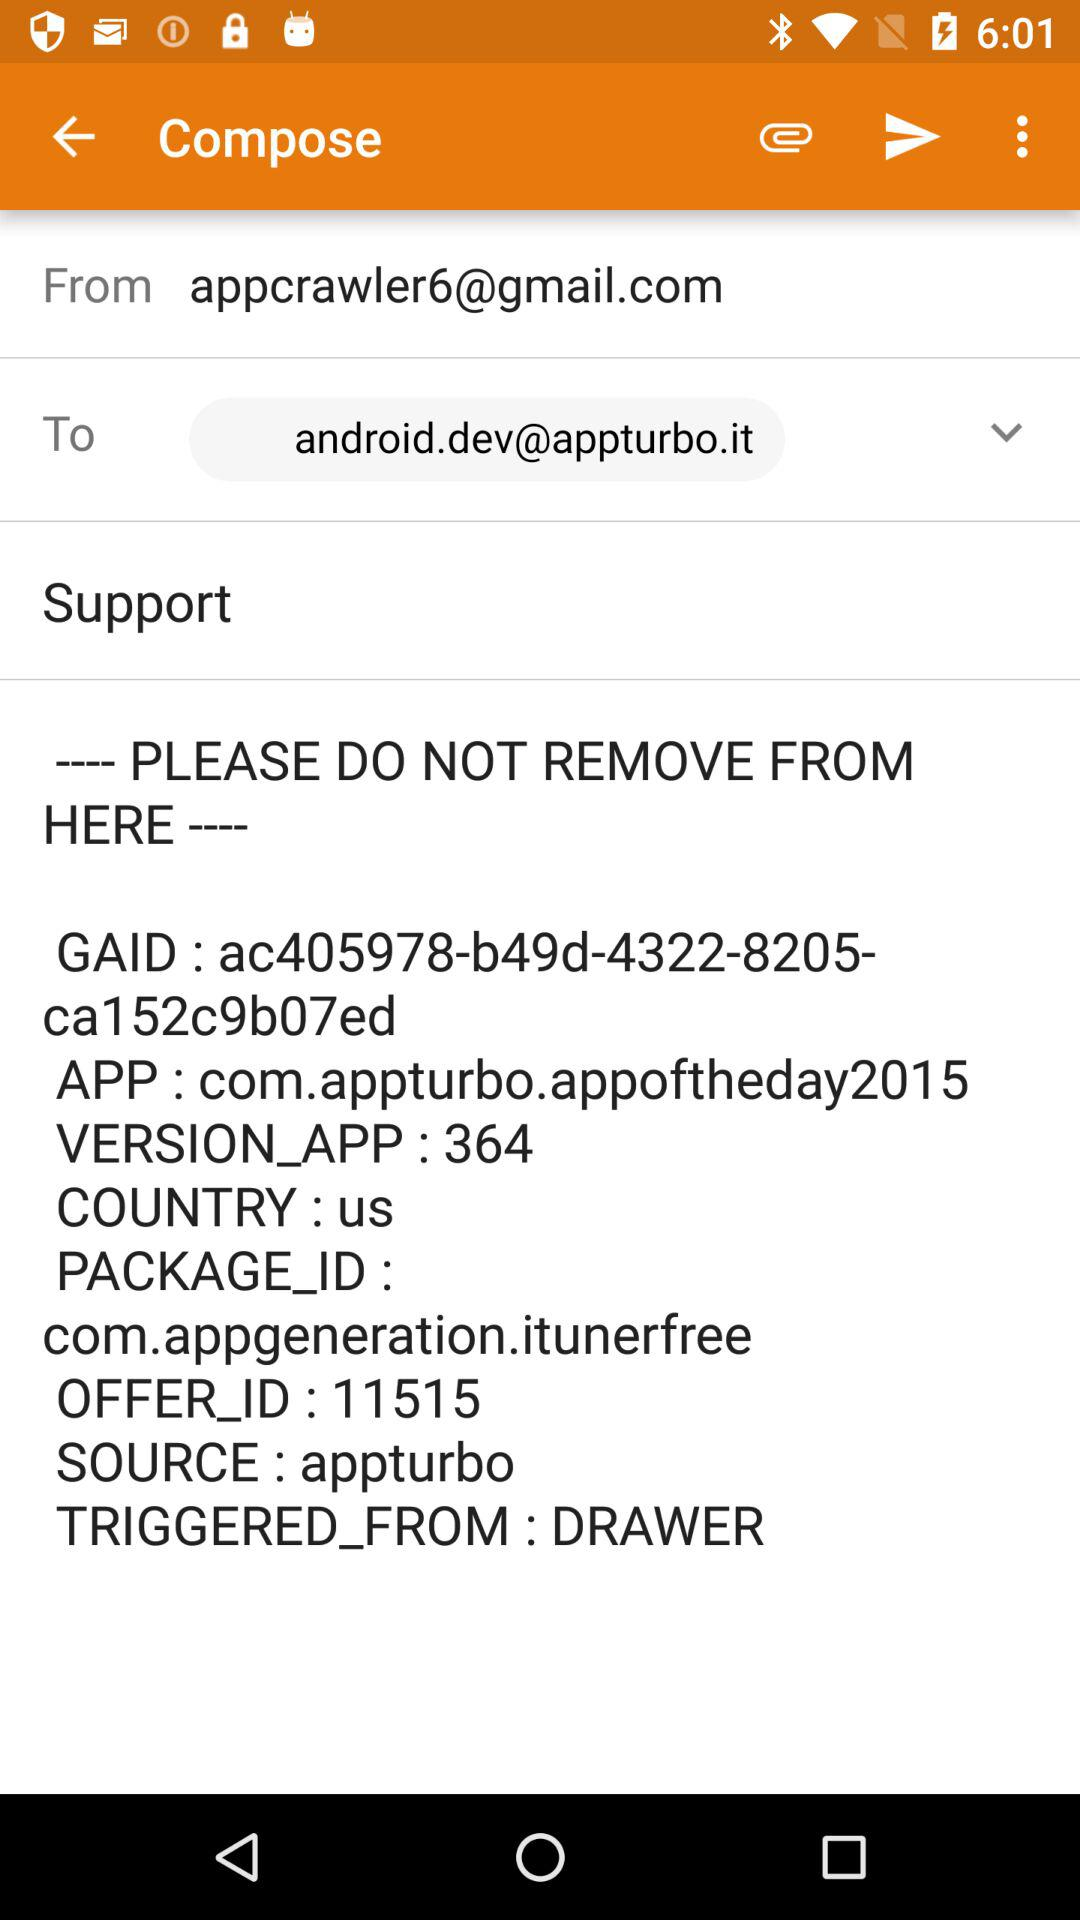What email address is being used to send the message? The email address that is being used to send the message is appcrawler6@gmail.com. 